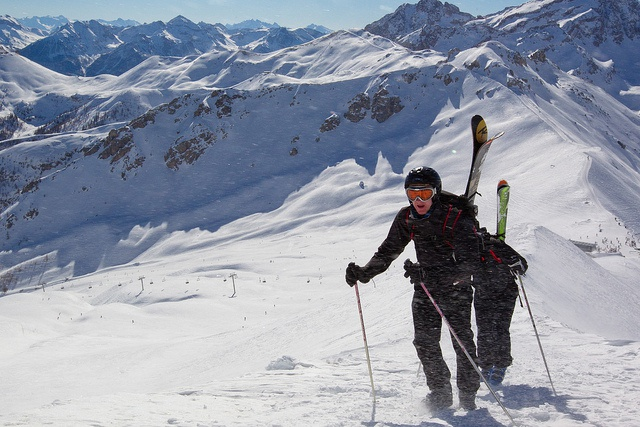Describe the objects in this image and their specific colors. I can see people in lightblue, black, gray, darkgray, and maroon tones, people in lightblue, black, gray, and lightgray tones, skis in lightblue, gray, black, darkgray, and olive tones, backpack in lightblue, black, gray, maroon, and darkgray tones, and backpack in lightblue, black, gray, lightgray, and darkgray tones in this image. 